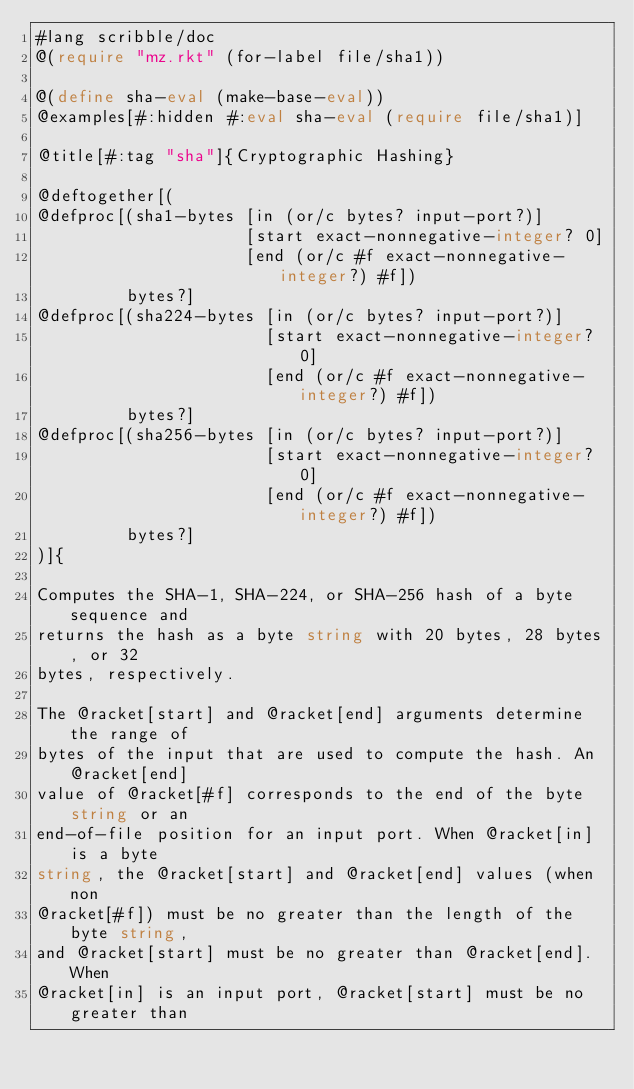Convert code to text. <code><loc_0><loc_0><loc_500><loc_500><_Racket_>#lang scribble/doc
@(require "mz.rkt" (for-label file/sha1))

@(define sha-eval (make-base-eval))
@examples[#:hidden #:eval sha-eval (require file/sha1)]

@title[#:tag "sha"]{Cryptographic Hashing}

@deftogether[(
@defproc[(sha1-bytes [in (or/c bytes? input-port?)]
                     [start exact-nonnegative-integer? 0]
                     [end (or/c #f exact-nonnegative-integer?) #f])
         bytes?]
@defproc[(sha224-bytes [in (or/c bytes? input-port?)]
                       [start exact-nonnegative-integer? 0]
                       [end (or/c #f exact-nonnegative-integer?) #f])
         bytes?]
@defproc[(sha256-bytes [in (or/c bytes? input-port?)]
                       [start exact-nonnegative-integer? 0]
                       [end (or/c #f exact-nonnegative-integer?) #f])
         bytes?]
)]{

Computes the SHA-1, SHA-224, or SHA-256 hash of a byte sequence and
returns the hash as a byte string with 20 bytes, 28 bytes, or 32
bytes, respectively.

The @racket[start] and @racket[end] arguments determine the range of
bytes of the input that are used to compute the hash. An @racket[end]
value of @racket[#f] corresponds to the end of the byte string or an
end-of-file position for an input port. When @racket[in] is a byte
string, the @racket[start] and @racket[end] values (when non
@racket[#f]) must be no greater than the length of the byte string,
and @racket[start] must be no greater than @racket[end]. When
@racket[in] is an input port, @racket[start] must be no greater than</code> 